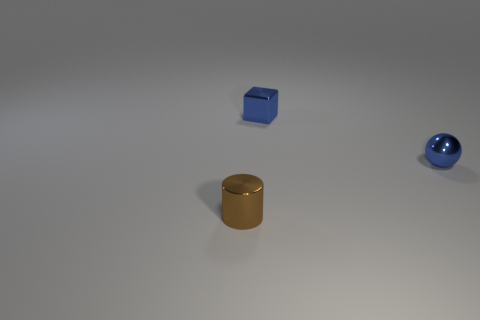Do the block and the small sphere have the same color?
Your response must be concise. Yes. The brown metallic thing is what shape?
Make the answer very short. Cylinder. Do the blue ball and the object to the left of the blue cube have the same material?
Give a very brief answer. Yes. How many things are blue rubber things or blocks?
Your answer should be very brief. 1. Is there a tiny purple metallic cube?
Offer a terse response. No. There is a blue shiny thing that is on the right side of the blue thing behind the blue ball; what shape is it?
Provide a short and direct response. Sphere. What number of objects are blue objects behind the sphere or small shiny objects that are behind the brown metal object?
Offer a very short reply. 2. There is a cylinder that is the same size as the blue ball; what material is it?
Your answer should be very brief. Metal. The cylinder has what color?
Offer a very short reply. Brown. What is the tiny object that is left of the metal sphere and on the right side of the small brown cylinder made of?
Give a very brief answer. Metal. 